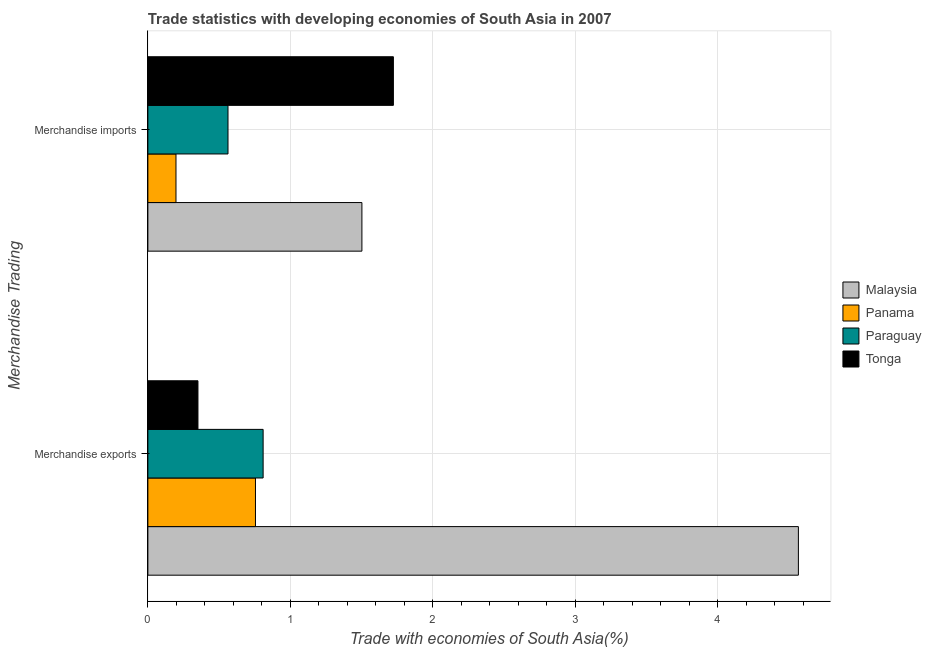How many groups of bars are there?
Offer a terse response. 2. Are the number of bars on each tick of the Y-axis equal?
Ensure brevity in your answer.  Yes. How many bars are there on the 1st tick from the top?
Keep it short and to the point. 4. What is the merchandise imports in Tonga?
Provide a short and direct response. 1.72. Across all countries, what is the maximum merchandise imports?
Offer a very short reply. 1.72. Across all countries, what is the minimum merchandise exports?
Ensure brevity in your answer.  0.35. In which country was the merchandise exports maximum?
Your answer should be very brief. Malaysia. In which country was the merchandise exports minimum?
Your answer should be very brief. Tonga. What is the total merchandise exports in the graph?
Offer a very short reply. 6.48. What is the difference between the merchandise exports in Malaysia and that in Panama?
Your answer should be compact. 3.81. What is the difference between the merchandise exports in Paraguay and the merchandise imports in Malaysia?
Keep it short and to the point. -0.69. What is the average merchandise exports per country?
Keep it short and to the point. 1.62. What is the difference between the merchandise imports and merchandise exports in Tonga?
Your response must be concise. 1.37. In how many countries, is the merchandise imports greater than 4.2 %?
Offer a terse response. 0. What is the ratio of the merchandise imports in Panama to that in Malaysia?
Your answer should be compact. 0.13. Is the merchandise imports in Panama less than that in Tonga?
Make the answer very short. Yes. What does the 3rd bar from the top in Merchandise imports represents?
Provide a short and direct response. Panama. What does the 4th bar from the bottom in Merchandise imports represents?
Give a very brief answer. Tonga. How many bars are there?
Provide a short and direct response. 8. How many countries are there in the graph?
Your answer should be very brief. 4. Are the values on the major ticks of X-axis written in scientific E-notation?
Provide a short and direct response. No. Where does the legend appear in the graph?
Make the answer very short. Center right. How are the legend labels stacked?
Give a very brief answer. Vertical. What is the title of the graph?
Keep it short and to the point. Trade statistics with developing economies of South Asia in 2007. What is the label or title of the X-axis?
Offer a terse response. Trade with economies of South Asia(%). What is the label or title of the Y-axis?
Provide a short and direct response. Merchandise Trading. What is the Trade with economies of South Asia(%) of Malaysia in Merchandise exports?
Your answer should be very brief. 4.57. What is the Trade with economies of South Asia(%) of Panama in Merchandise exports?
Your answer should be compact. 0.76. What is the Trade with economies of South Asia(%) of Paraguay in Merchandise exports?
Give a very brief answer. 0.81. What is the Trade with economies of South Asia(%) of Tonga in Merchandise exports?
Keep it short and to the point. 0.35. What is the Trade with economies of South Asia(%) of Malaysia in Merchandise imports?
Ensure brevity in your answer.  1.5. What is the Trade with economies of South Asia(%) in Panama in Merchandise imports?
Ensure brevity in your answer.  0.2. What is the Trade with economies of South Asia(%) of Paraguay in Merchandise imports?
Provide a short and direct response. 0.56. What is the Trade with economies of South Asia(%) in Tonga in Merchandise imports?
Give a very brief answer. 1.72. Across all Merchandise Trading, what is the maximum Trade with economies of South Asia(%) in Malaysia?
Keep it short and to the point. 4.57. Across all Merchandise Trading, what is the maximum Trade with economies of South Asia(%) in Panama?
Offer a very short reply. 0.76. Across all Merchandise Trading, what is the maximum Trade with economies of South Asia(%) of Paraguay?
Make the answer very short. 0.81. Across all Merchandise Trading, what is the maximum Trade with economies of South Asia(%) in Tonga?
Your response must be concise. 1.72. Across all Merchandise Trading, what is the minimum Trade with economies of South Asia(%) in Malaysia?
Your answer should be compact. 1.5. Across all Merchandise Trading, what is the minimum Trade with economies of South Asia(%) of Panama?
Provide a succinct answer. 0.2. Across all Merchandise Trading, what is the minimum Trade with economies of South Asia(%) of Paraguay?
Keep it short and to the point. 0.56. Across all Merchandise Trading, what is the minimum Trade with economies of South Asia(%) of Tonga?
Your answer should be compact. 0.35. What is the total Trade with economies of South Asia(%) of Malaysia in the graph?
Make the answer very short. 6.07. What is the total Trade with economies of South Asia(%) of Panama in the graph?
Keep it short and to the point. 0.95. What is the total Trade with economies of South Asia(%) in Paraguay in the graph?
Keep it short and to the point. 1.37. What is the total Trade with economies of South Asia(%) in Tonga in the graph?
Offer a very short reply. 2.08. What is the difference between the Trade with economies of South Asia(%) of Malaysia in Merchandise exports and that in Merchandise imports?
Your answer should be compact. 3.06. What is the difference between the Trade with economies of South Asia(%) in Panama in Merchandise exports and that in Merchandise imports?
Your answer should be compact. 0.56. What is the difference between the Trade with economies of South Asia(%) in Paraguay in Merchandise exports and that in Merchandise imports?
Your answer should be very brief. 0.25. What is the difference between the Trade with economies of South Asia(%) in Tonga in Merchandise exports and that in Merchandise imports?
Offer a terse response. -1.37. What is the difference between the Trade with economies of South Asia(%) of Malaysia in Merchandise exports and the Trade with economies of South Asia(%) of Panama in Merchandise imports?
Provide a succinct answer. 4.37. What is the difference between the Trade with economies of South Asia(%) in Malaysia in Merchandise exports and the Trade with economies of South Asia(%) in Paraguay in Merchandise imports?
Offer a very short reply. 4. What is the difference between the Trade with economies of South Asia(%) in Malaysia in Merchandise exports and the Trade with economies of South Asia(%) in Tonga in Merchandise imports?
Provide a succinct answer. 2.84. What is the difference between the Trade with economies of South Asia(%) of Panama in Merchandise exports and the Trade with economies of South Asia(%) of Paraguay in Merchandise imports?
Your answer should be very brief. 0.19. What is the difference between the Trade with economies of South Asia(%) of Panama in Merchandise exports and the Trade with economies of South Asia(%) of Tonga in Merchandise imports?
Offer a terse response. -0.97. What is the difference between the Trade with economies of South Asia(%) of Paraguay in Merchandise exports and the Trade with economies of South Asia(%) of Tonga in Merchandise imports?
Provide a succinct answer. -0.91. What is the average Trade with economies of South Asia(%) of Malaysia per Merchandise Trading?
Ensure brevity in your answer.  3.04. What is the average Trade with economies of South Asia(%) in Panama per Merchandise Trading?
Provide a succinct answer. 0.48. What is the average Trade with economies of South Asia(%) of Paraguay per Merchandise Trading?
Ensure brevity in your answer.  0.69. What is the average Trade with economies of South Asia(%) in Tonga per Merchandise Trading?
Keep it short and to the point. 1.04. What is the difference between the Trade with economies of South Asia(%) of Malaysia and Trade with economies of South Asia(%) of Panama in Merchandise exports?
Provide a short and direct response. 3.81. What is the difference between the Trade with economies of South Asia(%) in Malaysia and Trade with economies of South Asia(%) in Paraguay in Merchandise exports?
Ensure brevity in your answer.  3.76. What is the difference between the Trade with economies of South Asia(%) in Malaysia and Trade with economies of South Asia(%) in Tonga in Merchandise exports?
Keep it short and to the point. 4.22. What is the difference between the Trade with economies of South Asia(%) in Panama and Trade with economies of South Asia(%) in Paraguay in Merchandise exports?
Make the answer very short. -0.05. What is the difference between the Trade with economies of South Asia(%) of Panama and Trade with economies of South Asia(%) of Tonga in Merchandise exports?
Provide a short and direct response. 0.4. What is the difference between the Trade with economies of South Asia(%) of Paraguay and Trade with economies of South Asia(%) of Tonga in Merchandise exports?
Your response must be concise. 0.46. What is the difference between the Trade with economies of South Asia(%) in Malaysia and Trade with economies of South Asia(%) in Panama in Merchandise imports?
Offer a terse response. 1.31. What is the difference between the Trade with economies of South Asia(%) of Malaysia and Trade with economies of South Asia(%) of Paraguay in Merchandise imports?
Offer a terse response. 0.94. What is the difference between the Trade with economies of South Asia(%) of Malaysia and Trade with economies of South Asia(%) of Tonga in Merchandise imports?
Offer a terse response. -0.22. What is the difference between the Trade with economies of South Asia(%) in Panama and Trade with economies of South Asia(%) in Paraguay in Merchandise imports?
Give a very brief answer. -0.37. What is the difference between the Trade with economies of South Asia(%) in Panama and Trade with economies of South Asia(%) in Tonga in Merchandise imports?
Provide a succinct answer. -1.53. What is the difference between the Trade with economies of South Asia(%) in Paraguay and Trade with economies of South Asia(%) in Tonga in Merchandise imports?
Provide a short and direct response. -1.16. What is the ratio of the Trade with economies of South Asia(%) in Malaysia in Merchandise exports to that in Merchandise imports?
Your response must be concise. 3.04. What is the ratio of the Trade with economies of South Asia(%) of Panama in Merchandise exports to that in Merchandise imports?
Provide a short and direct response. 3.83. What is the ratio of the Trade with economies of South Asia(%) in Paraguay in Merchandise exports to that in Merchandise imports?
Your answer should be compact. 1.44. What is the ratio of the Trade with economies of South Asia(%) of Tonga in Merchandise exports to that in Merchandise imports?
Make the answer very short. 0.2. What is the difference between the highest and the second highest Trade with economies of South Asia(%) of Malaysia?
Make the answer very short. 3.06. What is the difference between the highest and the second highest Trade with economies of South Asia(%) in Panama?
Your response must be concise. 0.56. What is the difference between the highest and the second highest Trade with economies of South Asia(%) of Paraguay?
Your answer should be very brief. 0.25. What is the difference between the highest and the second highest Trade with economies of South Asia(%) in Tonga?
Your answer should be very brief. 1.37. What is the difference between the highest and the lowest Trade with economies of South Asia(%) of Malaysia?
Keep it short and to the point. 3.06. What is the difference between the highest and the lowest Trade with economies of South Asia(%) in Panama?
Offer a terse response. 0.56. What is the difference between the highest and the lowest Trade with economies of South Asia(%) of Paraguay?
Offer a very short reply. 0.25. What is the difference between the highest and the lowest Trade with economies of South Asia(%) in Tonga?
Your answer should be very brief. 1.37. 